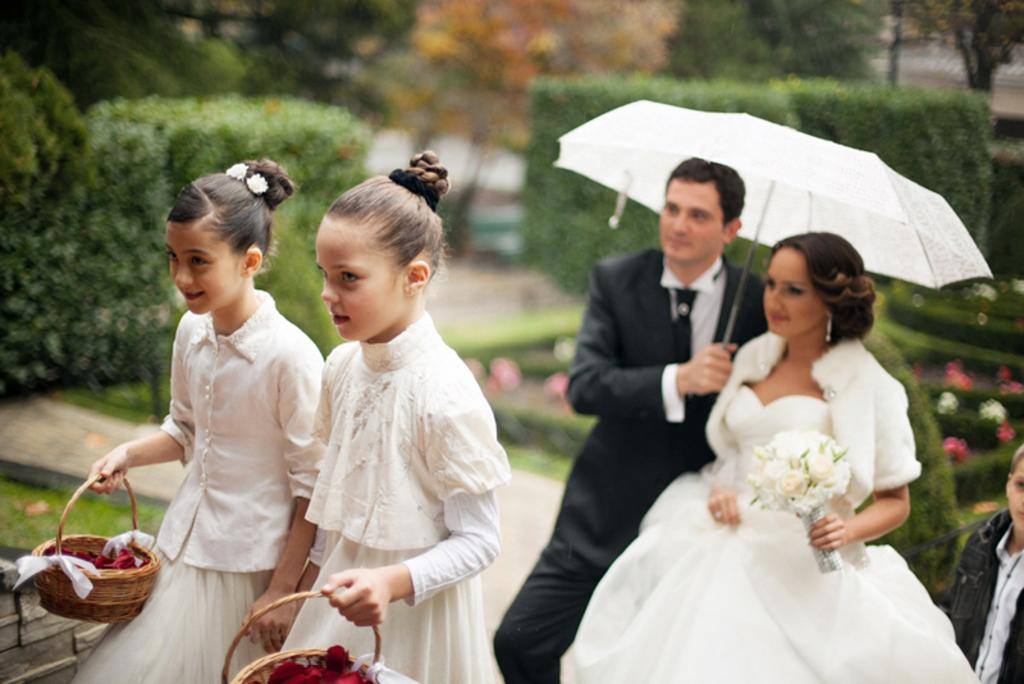What are the persons in the image doing? The persons in the image are walking. What are the persons holding in their hands? The persons are holding objects in their hands. What can be seen in the background of the image? There are trees, flowers, and plants in the background of the image. What type of vegetation is on the ground in the image? There is grass on the ground in the image. What type of prose can be heard being recited by the persons in the image? There is no indication in the image that the persons are reciting any prose, so it cannot be determined from the picture. 